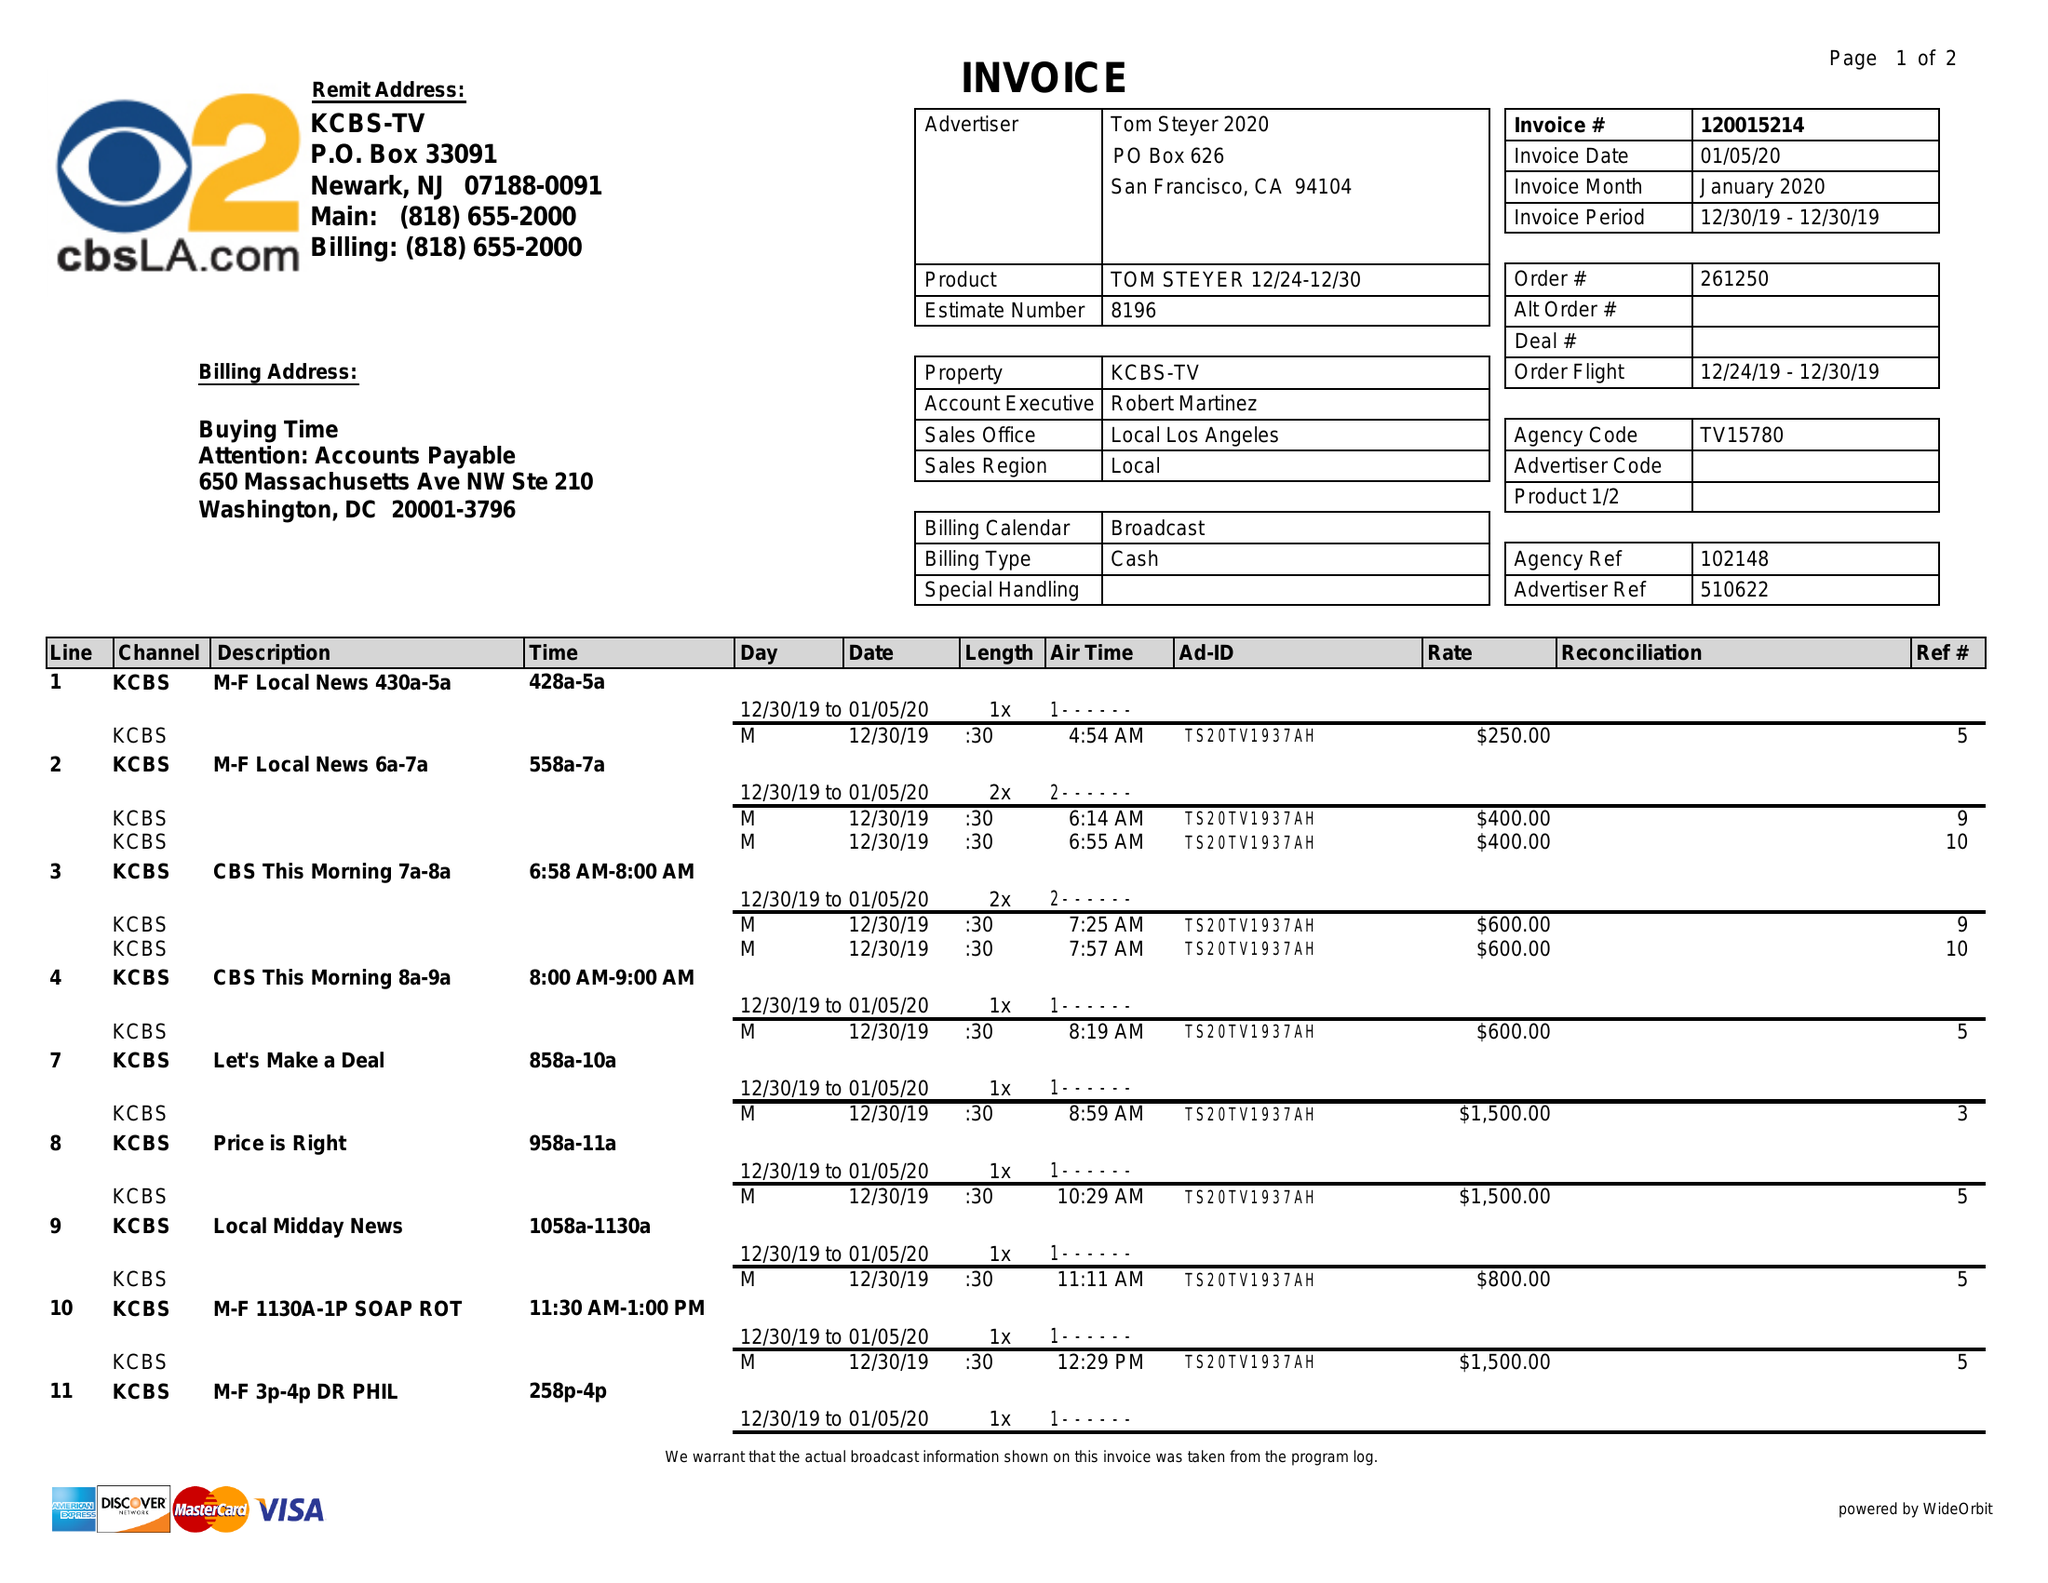What is the value for the flight_from?
Answer the question using a single word or phrase. 12/24/19 